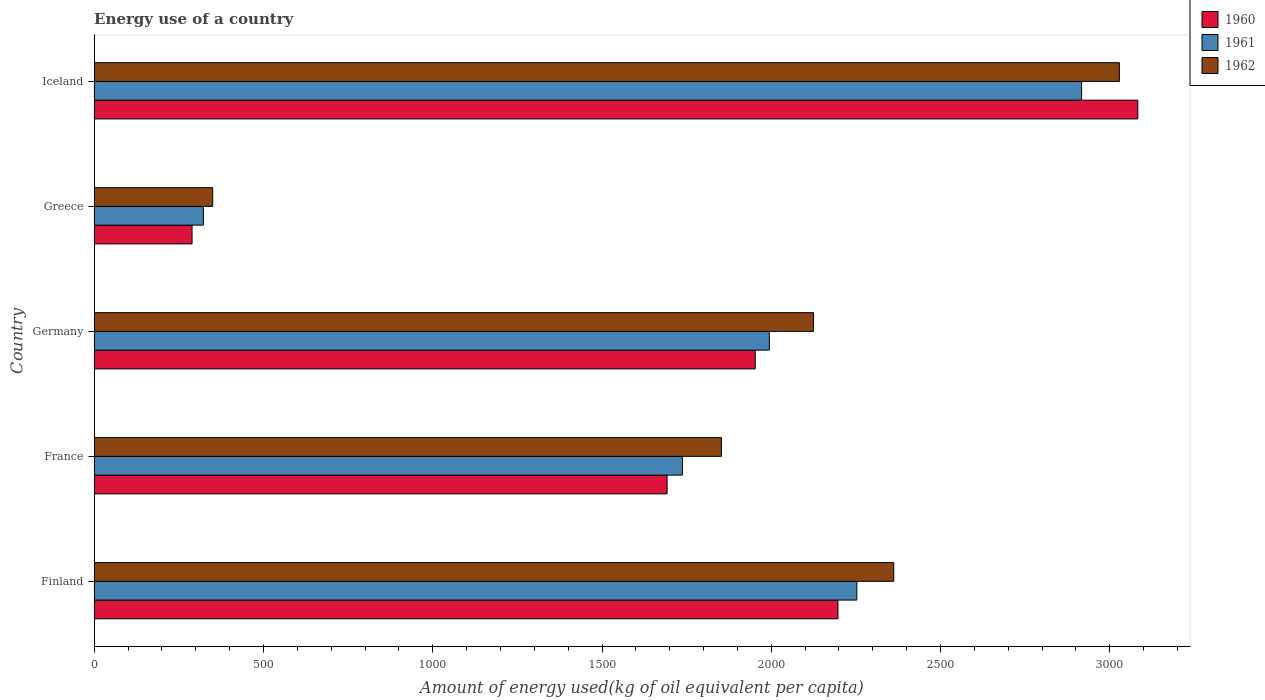How many different coloured bars are there?
Your answer should be very brief. 3. Are the number of bars per tick equal to the number of legend labels?
Give a very brief answer. Yes. What is the amount of energy used in in 1962 in France?
Keep it short and to the point. 1852.74. Across all countries, what is the maximum amount of energy used in in 1960?
Provide a succinct answer. 3082.71. Across all countries, what is the minimum amount of energy used in in 1961?
Your answer should be very brief. 322.49. In which country was the amount of energy used in in 1962 maximum?
Your answer should be very brief. Iceland. In which country was the amount of energy used in in 1960 minimum?
Make the answer very short. Greece. What is the total amount of energy used in in 1961 in the graph?
Offer a terse response. 9223.99. What is the difference between the amount of energy used in in 1961 in France and that in Greece?
Provide a succinct answer. 1415.2. What is the difference between the amount of energy used in in 1961 in Iceland and the amount of energy used in in 1960 in France?
Your answer should be very brief. 1224.44. What is the average amount of energy used in in 1961 per country?
Offer a very short reply. 1844.8. What is the difference between the amount of energy used in in 1962 and amount of energy used in in 1960 in Germany?
Offer a terse response. 172.26. What is the ratio of the amount of energy used in in 1960 in Finland to that in Greece?
Provide a succinct answer. 7.6. Is the amount of energy used in in 1960 in Germany less than that in Greece?
Your response must be concise. No. What is the difference between the highest and the second highest amount of energy used in in 1960?
Give a very brief answer. 885.76. What is the difference between the highest and the lowest amount of energy used in in 1961?
Provide a succinct answer. 2594.22. What does the 1st bar from the top in Germany represents?
Offer a very short reply. 1962. What does the 1st bar from the bottom in Greece represents?
Provide a short and direct response. 1960. How many bars are there?
Provide a succinct answer. 15. What is the difference between two consecutive major ticks on the X-axis?
Provide a short and direct response. 500. Are the values on the major ticks of X-axis written in scientific E-notation?
Give a very brief answer. No. Does the graph contain any zero values?
Ensure brevity in your answer.  No. Does the graph contain grids?
Offer a very short reply. No. How many legend labels are there?
Keep it short and to the point. 3. What is the title of the graph?
Your answer should be very brief. Energy use of a country. Does "1994" appear as one of the legend labels in the graph?
Offer a very short reply. No. What is the label or title of the X-axis?
Make the answer very short. Amount of energy used(kg of oil equivalent per capita). What is the label or title of the Y-axis?
Provide a short and direct response. Country. What is the Amount of energy used(kg of oil equivalent per capita) of 1960 in Finland?
Provide a succinct answer. 2196.95. What is the Amount of energy used(kg of oil equivalent per capita) in 1961 in Finland?
Your answer should be very brief. 2252.78. What is the Amount of energy used(kg of oil equivalent per capita) of 1962 in Finland?
Provide a short and direct response. 2361.74. What is the Amount of energy used(kg of oil equivalent per capita) of 1960 in France?
Offer a very short reply. 1692.26. What is the Amount of energy used(kg of oil equivalent per capita) in 1961 in France?
Keep it short and to the point. 1737.69. What is the Amount of energy used(kg of oil equivalent per capita) of 1962 in France?
Your answer should be very brief. 1852.74. What is the Amount of energy used(kg of oil equivalent per capita) of 1960 in Germany?
Ensure brevity in your answer.  1952.59. What is the Amount of energy used(kg of oil equivalent per capita) in 1961 in Germany?
Provide a succinct answer. 1994.32. What is the Amount of energy used(kg of oil equivalent per capita) of 1962 in Germany?
Give a very brief answer. 2124.85. What is the Amount of energy used(kg of oil equivalent per capita) in 1960 in Greece?
Ensure brevity in your answer.  289.06. What is the Amount of energy used(kg of oil equivalent per capita) of 1961 in Greece?
Offer a terse response. 322.49. What is the Amount of energy used(kg of oil equivalent per capita) of 1962 in Greece?
Offer a very short reply. 350.1. What is the Amount of energy used(kg of oil equivalent per capita) in 1960 in Iceland?
Your answer should be very brief. 3082.71. What is the Amount of energy used(kg of oil equivalent per capita) in 1961 in Iceland?
Give a very brief answer. 2916.71. What is the Amount of energy used(kg of oil equivalent per capita) of 1962 in Iceland?
Keep it short and to the point. 3028.3. Across all countries, what is the maximum Amount of energy used(kg of oil equivalent per capita) of 1960?
Provide a succinct answer. 3082.71. Across all countries, what is the maximum Amount of energy used(kg of oil equivalent per capita) of 1961?
Make the answer very short. 2916.71. Across all countries, what is the maximum Amount of energy used(kg of oil equivalent per capita) in 1962?
Keep it short and to the point. 3028.3. Across all countries, what is the minimum Amount of energy used(kg of oil equivalent per capita) of 1960?
Provide a succinct answer. 289.06. Across all countries, what is the minimum Amount of energy used(kg of oil equivalent per capita) of 1961?
Ensure brevity in your answer.  322.49. Across all countries, what is the minimum Amount of energy used(kg of oil equivalent per capita) of 1962?
Give a very brief answer. 350.1. What is the total Amount of energy used(kg of oil equivalent per capita) of 1960 in the graph?
Give a very brief answer. 9213.57. What is the total Amount of energy used(kg of oil equivalent per capita) of 1961 in the graph?
Give a very brief answer. 9223.99. What is the total Amount of energy used(kg of oil equivalent per capita) in 1962 in the graph?
Give a very brief answer. 9717.73. What is the difference between the Amount of energy used(kg of oil equivalent per capita) of 1960 in Finland and that in France?
Your response must be concise. 504.69. What is the difference between the Amount of energy used(kg of oil equivalent per capita) in 1961 in Finland and that in France?
Keep it short and to the point. 515.09. What is the difference between the Amount of energy used(kg of oil equivalent per capita) in 1962 in Finland and that in France?
Provide a succinct answer. 509.01. What is the difference between the Amount of energy used(kg of oil equivalent per capita) of 1960 in Finland and that in Germany?
Your answer should be very brief. 244.36. What is the difference between the Amount of energy used(kg of oil equivalent per capita) in 1961 in Finland and that in Germany?
Give a very brief answer. 258.45. What is the difference between the Amount of energy used(kg of oil equivalent per capita) of 1962 in Finland and that in Germany?
Keep it short and to the point. 236.9. What is the difference between the Amount of energy used(kg of oil equivalent per capita) in 1960 in Finland and that in Greece?
Your response must be concise. 1907.9. What is the difference between the Amount of energy used(kg of oil equivalent per capita) of 1961 in Finland and that in Greece?
Your answer should be very brief. 1930.29. What is the difference between the Amount of energy used(kg of oil equivalent per capita) of 1962 in Finland and that in Greece?
Your answer should be very brief. 2011.64. What is the difference between the Amount of energy used(kg of oil equivalent per capita) of 1960 in Finland and that in Iceland?
Provide a short and direct response. -885.76. What is the difference between the Amount of energy used(kg of oil equivalent per capita) of 1961 in Finland and that in Iceland?
Your response must be concise. -663.93. What is the difference between the Amount of energy used(kg of oil equivalent per capita) of 1962 in Finland and that in Iceland?
Your answer should be very brief. -666.55. What is the difference between the Amount of energy used(kg of oil equivalent per capita) of 1960 in France and that in Germany?
Your answer should be compact. -260.33. What is the difference between the Amount of energy used(kg of oil equivalent per capita) of 1961 in France and that in Germany?
Offer a very short reply. -256.64. What is the difference between the Amount of energy used(kg of oil equivalent per capita) in 1962 in France and that in Germany?
Provide a short and direct response. -272.11. What is the difference between the Amount of energy used(kg of oil equivalent per capita) in 1960 in France and that in Greece?
Your response must be concise. 1403.2. What is the difference between the Amount of energy used(kg of oil equivalent per capita) in 1961 in France and that in Greece?
Offer a very short reply. 1415.2. What is the difference between the Amount of energy used(kg of oil equivalent per capita) of 1962 in France and that in Greece?
Provide a short and direct response. 1502.63. What is the difference between the Amount of energy used(kg of oil equivalent per capita) in 1960 in France and that in Iceland?
Keep it short and to the point. -1390.45. What is the difference between the Amount of energy used(kg of oil equivalent per capita) in 1961 in France and that in Iceland?
Offer a terse response. -1179.02. What is the difference between the Amount of energy used(kg of oil equivalent per capita) in 1962 in France and that in Iceland?
Provide a short and direct response. -1175.56. What is the difference between the Amount of energy used(kg of oil equivalent per capita) in 1960 in Germany and that in Greece?
Your answer should be compact. 1663.53. What is the difference between the Amount of energy used(kg of oil equivalent per capita) in 1961 in Germany and that in Greece?
Offer a terse response. 1671.83. What is the difference between the Amount of energy used(kg of oil equivalent per capita) of 1962 in Germany and that in Greece?
Make the answer very short. 1774.75. What is the difference between the Amount of energy used(kg of oil equivalent per capita) of 1960 in Germany and that in Iceland?
Give a very brief answer. -1130.12. What is the difference between the Amount of energy used(kg of oil equivalent per capita) in 1961 in Germany and that in Iceland?
Ensure brevity in your answer.  -922.38. What is the difference between the Amount of energy used(kg of oil equivalent per capita) in 1962 in Germany and that in Iceland?
Keep it short and to the point. -903.45. What is the difference between the Amount of energy used(kg of oil equivalent per capita) of 1960 in Greece and that in Iceland?
Provide a succinct answer. -2793.65. What is the difference between the Amount of energy used(kg of oil equivalent per capita) in 1961 in Greece and that in Iceland?
Ensure brevity in your answer.  -2594.22. What is the difference between the Amount of energy used(kg of oil equivalent per capita) of 1962 in Greece and that in Iceland?
Provide a short and direct response. -2678.2. What is the difference between the Amount of energy used(kg of oil equivalent per capita) in 1960 in Finland and the Amount of energy used(kg of oil equivalent per capita) in 1961 in France?
Provide a short and direct response. 459.26. What is the difference between the Amount of energy used(kg of oil equivalent per capita) of 1960 in Finland and the Amount of energy used(kg of oil equivalent per capita) of 1962 in France?
Provide a succinct answer. 344.22. What is the difference between the Amount of energy used(kg of oil equivalent per capita) of 1961 in Finland and the Amount of energy used(kg of oil equivalent per capita) of 1962 in France?
Keep it short and to the point. 400.04. What is the difference between the Amount of energy used(kg of oil equivalent per capita) of 1960 in Finland and the Amount of energy used(kg of oil equivalent per capita) of 1961 in Germany?
Ensure brevity in your answer.  202.63. What is the difference between the Amount of energy used(kg of oil equivalent per capita) of 1960 in Finland and the Amount of energy used(kg of oil equivalent per capita) of 1962 in Germany?
Your response must be concise. 72.1. What is the difference between the Amount of energy used(kg of oil equivalent per capita) in 1961 in Finland and the Amount of energy used(kg of oil equivalent per capita) in 1962 in Germany?
Provide a succinct answer. 127.93. What is the difference between the Amount of energy used(kg of oil equivalent per capita) of 1960 in Finland and the Amount of energy used(kg of oil equivalent per capita) of 1961 in Greece?
Your answer should be compact. 1874.46. What is the difference between the Amount of energy used(kg of oil equivalent per capita) in 1960 in Finland and the Amount of energy used(kg of oil equivalent per capita) in 1962 in Greece?
Give a very brief answer. 1846.85. What is the difference between the Amount of energy used(kg of oil equivalent per capita) of 1961 in Finland and the Amount of energy used(kg of oil equivalent per capita) of 1962 in Greece?
Offer a terse response. 1902.68. What is the difference between the Amount of energy used(kg of oil equivalent per capita) of 1960 in Finland and the Amount of energy used(kg of oil equivalent per capita) of 1961 in Iceland?
Make the answer very short. -719.75. What is the difference between the Amount of energy used(kg of oil equivalent per capita) in 1960 in Finland and the Amount of energy used(kg of oil equivalent per capita) in 1962 in Iceland?
Ensure brevity in your answer.  -831.35. What is the difference between the Amount of energy used(kg of oil equivalent per capita) in 1961 in Finland and the Amount of energy used(kg of oil equivalent per capita) in 1962 in Iceland?
Offer a very short reply. -775.52. What is the difference between the Amount of energy used(kg of oil equivalent per capita) in 1960 in France and the Amount of energy used(kg of oil equivalent per capita) in 1961 in Germany?
Offer a very short reply. -302.06. What is the difference between the Amount of energy used(kg of oil equivalent per capita) of 1960 in France and the Amount of energy used(kg of oil equivalent per capita) of 1962 in Germany?
Your answer should be compact. -432.59. What is the difference between the Amount of energy used(kg of oil equivalent per capita) of 1961 in France and the Amount of energy used(kg of oil equivalent per capita) of 1962 in Germany?
Ensure brevity in your answer.  -387.16. What is the difference between the Amount of energy used(kg of oil equivalent per capita) of 1960 in France and the Amount of energy used(kg of oil equivalent per capita) of 1961 in Greece?
Provide a short and direct response. 1369.77. What is the difference between the Amount of energy used(kg of oil equivalent per capita) of 1960 in France and the Amount of energy used(kg of oil equivalent per capita) of 1962 in Greece?
Provide a succinct answer. 1342.16. What is the difference between the Amount of energy used(kg of oil equivalent per capita) of 1961 in France and the Amount of energy used(kg of oil equivalent per capita) of 1962 in Greece?
Offer a very short reply. 1387.59. What is the difference between the Amount of energy used(kg of oil equivalent per capita) of 1960 in France and the Amount of energy used(kg of oil equivalent per capita) of 1961 in Iceland?
Give a very brief answer. -1224.44. What is the difference between the Amount of energy used(kg of oil equivalent per capita) of 1960 in France and the Amount of energy used(kg of oil equivalent per capita) of 1962 in Iceland?
Offer a terse response. -1336.04. What is the difference between the Amount of energy used(kg of oil equivalent per capita) of 1961 in France and the Amount of energy used(kg of oil equivalent per capita) of 1962 in Iceland?
Make the answer very short. -1290.61. What is the difference between the Amount of energy used(kg of oil equivalent per capita) in 1960 in Germany and the Amount of energy used(kg of oil equivalent per capita) in 1961 in Greece?
Give a very brief answer. 1630.1. What is the difference between the Amount of energy used(kg of oil equivalent per capita) of 1960 in Germany and the Amount of energy used(kg of oil equivalent per capita) of 1962 in Greece?
Make the answer very short. 1602.49. What is the difference between the Amount of energy used(kg of oil equivalent per capita) of 1961 in Germany and the Amount of energy used(kg of oil equivalent per capita) of 1962 in Greece?
Your response must be concise. 1644.22. What is the difference between the Amount of energy used(kg of oil equivalent per capita) in 1960 in Germany and the Amount of energy used(kg of oil equivalent per capita) in 1961 in Iceland?
Offer a terse response. -964.12. What is the difference between the Amount of energy used(kg of oil equivalent per capita) of 1960 in Germany and the Amount of energy used(kg of oil equivalent per capita) of 1962 in Iceland?
Provide a short and direct response. -1075.71. What is the difference between the Amount of energy used(kg of oil equivalent per capita) in 1961 in Germany and the Amount of energy used(kg of oil equivalent per capita) in 1962 in Iceland?
Give a very brief answer. -1033.97. What is the difference between the Amount of energy used(kg of oil equivalent per capita) of 1960 in Greece and the Amount of energy used(kg of oil equivalent per capita) of 1961 in Iceland?
Offer a terse response. -2627.65. What is the difference between the Amount of energy used(kg of oil equivalent per capita) in 1960 in Greece and the Amount of energy used(kg of oil equivalent per capita) in 1962 in Iceland?
Your answer should be compact. -2739.24. What is the difference between the Amount of energy used(kg of oil equivalent per capita) in 1961 in Greece and the Amount of energy used(kg of oil equivalent per capita) in 1962 in Iceland?
Your answer should be very brief. -2705.81. What is the average Amount of energy used(kg of oil equivalent per capita) in 1960 per country?
Offer a terse response. 1842.71. What is the average Amount of energy used(kg of oil equivalent per capita) in 1961 per country?
Your answer should be very brief. 1844.8. What is the average Amount of energy used(kg of oil equivalent per capita) in 1962 per country?
Give a very brief answer. 1943.55. What is the difference between the Amount of energy used(kg of oil equivalent per capita) of 1960 and Amount of energy used(kg of oil equivalent per capita) of 1961 in Finland?
Offer a very short reply. -55.83. What is the difference between the Amount of energy used(kg of oil equivalent per capita) in 1960 and Amount of energy used(kg of oil equivalent per capita) in 1962 in Finland?
Your response must be concise. -164.79. What is the difference between the Amount of energy used(kg of oil equivalent per capita) of 1961 and Amount of energy used(kg of oil equivalent per capita) of 1962 in Finland?
Your response must be concise. -108.97. What is the difference between the Amount of energy used(kg of oil equivalent per capita) of 1960 and Amount of energy used(kg of oil equivalent per capita) of 1961 in France?
Provide a succinct answer. -45.43. What is the difference between the Amount of energy used(kg of oil equivalent per capita) of 1960 and Amount of energy used(kg of oil equivalent per capita) of 1962 in France?
Keep it short and to the point. -160.47. What is the difference between the Amount of energy used(kg of oil equivalent per capita) of 1961 and Amount of energy used(kg of oil equivalent per capita) of 1962 in France?
Your response must be concise. -115.05. What is the difference between the Amount of energy used(kg of oil equivalent per capita) in 1960 and Amount of energy used(kg of oil equivalent per capita) in 1961 in Germany?
Keep it short and to the point. -41.74. What is the difference between the Amount of energy used(kg of oil equivalent per capita) in 1960 and Amount of energy used(kg of oil equivalent per capita) in 1962 in Germany?
Your answer should be very brief. -172.26. What is the difference between the Amount of energy used(kg of oil equivalent per capita) in 1961 and Amount of energy used(kg of oil equivalent per capita) in 1962 in Germany?
Your response must be concise. -130.52. What is the difference between the Amount of energy used(kg of oil equivalent per capita) of 1960 and Amount of energy used(kg of oil equivalent per capita) of 1961 in Greece?
Make the answer very short. -33.43. What is the difference between the Amount of energy used(kg of oil equivalent per capita) in 1960 and Amount of energy used(kg of oil equivalent per capita) in 1962 in Greece?
Ensure brevity in your answer.  -61.04. What is the difference between the Amount of energy used(kg of oil equivalent per capita) in 1961 and Amount of energy used(kg of oil equivalent per capita) in 1962 in Greece?
Ensure brevity in your answer.  -27.61. What is the difference between the Amount of energy used(kg of oil equivalent per capita) of 1960 and Amount of energy used(kg of oil equivalent per capita) of 1961 in Iceland?
Give a very brief answer. 166.01. What is the difference between the Amount of energy used(kg of oil equivalent per capita) in 1960 and Amount of energy used(kg of oil equivalent per capita) in 1962 in Iceland?
Provide a short and direct response. 54.41. What is the difference between the Amount of energy used(kg of oil equivalent per capita) of 1961 and Amount of energy used(kg of oil equivalent per capita) of 1962 in Iceland?
Keep it short and to the point. -111.59. What is the ratio of the Amount of energy used(kg of oil equivalent per capita) of 1960 in Finland to that in France?
Give a very brief answer. 1.3. What is the ratio of the Amount of energy used(kg of oil equivalent per capita) in 1961 in Finland to that in France?
Provide a short and direct response. 1.3. What is the ratio of the Amount of energy used(kg of oil equivalent per capita) of 1962 in Finland to that in France?
Your answer should be very brief. 1.27. What is the ratio of the Amount of energy used(kg of oil equivalent per capita) in 1960 in Finland to that in Germany?
Ensure brevity in your answer.  1.13. What is the ratio of the Amount of energy used(kg of oil equivalent per capita) of 1961 in Finland to that in Germany?
Give a very brief answer. 1.13. What is the ratio of the Amount of energy used(kg of oil equivalent per capita) of 1962 in Finland to that in Germany?
Ensure brevity in your answer.  1.11. What is the ratio of the Amount of energy used(kg of oil equivalent per capita) in 1960 in Finland to that in Greece?
Offer a very short reply. 7.6. What is the ratio of the Amount of energy used(kg of oil equivalent per capita) in 1961 in Finland to that in Greece?
Ensure brevity in your answer.  6.99. What is the ratio of the Amount of energy used(kg of oil equivalent per capita) of 1962 in Finland to that in Greece?
Keep it short and to the point. 6.75. What is the ratio of the Amount of energy used(kg of oil equivalent per capita) in 1960 in Finland to that in Iceland?
Provide a succinct answer. 0.71. What is the ratio of the Amount of energy used(kg of oil equivalent per capita) of 1961 in Finland to that in Iceland?
Give a very brief answer. 0.77. What is the ratio of the Amount of energy used(kg of oil equivalent per capita) in 1962 in Finland to that in Iceland?
Offer a very short reply. 0.78. What is the ratio of the Amount of energy used(kg of oil equivalent per capita) in 1960 in France to that in Germany?
Offer a terse response. 0.87. What is the ratio of the Amount of energy used(kg of oil equivalent per capita) of 1961 in France to that in Germany?
Ensure brevity in your answer.  0.87. What is the ratio of the Amount of energy used(kg of oil equivalent per capita) in 1962 in France to that in Germany?
Offer a terse response. 0.87. What is the ratio of the Amount of energy used(kg of oil equivalent per capita) of 1960 in France to that in Greece?
Your response must be concise. 5.85. What is the ratio of the Amount of energy used(kg of oil equivalent per capita) in 1961 in France to that in Greece?
Provide a succinct answer. 5.39. What is the ratio of the Amount of energy used(kg of oil equivalent per capita) of 1962 in France to that in Greece?
Offer a very short reply. 5.29. What is the ratio of the Amount of energy used(kg of oil equivalent per capita) in 1960 in France to that in Iceland?
Keep it short and to the point. 0.55. What is the ratio of the Amount of energy used(kg of oil equivalent per capita) in 1961 in France to that in Iceland?
Offer a very short reply. 0.6. What is the ratio of the Amount of energy used(kg of oil equivalent per capita) of 1962 in France to that in Iceland?
Provide a succinct answer. 0.61. What is the ratio of the Amount of energy used(kg of oil equivalent per capita) in 1960 in Germany to that in Greece?
Make the answer very short. 6.75. What is the ratio of the Amount of energy used(kg of oil equivalent per capita) of 1961 in Germany to that in Greece?
Ensure brevity in your answer.  6.18. What is the ratio of the Amount of energy used(kg of oil equivalent per capita) in 1962 in Germany to that in Greece?
Ensure brevity in your answer.  6.07. What is the ratio of the Amount of energy used(kg of oil equivalent per capita) of 1960 in Germany to that in Iceland?
Your answer should be very brief. 0.63. What is the ratio of the Amount of energy used(kg of oil equivalent per capita) in 1961 in Germany to that in Iceland?
Make the answer very short. 0.68. What is the ratio of the Amount of energy used(kg of oil equivalent per capita) in 1962 in Germany to that in Iceland?
Keep it short and to the point. 0.7. What is the ratio of the Amount of energy used(kg of oil equivalent per capita) in 1960 in Greece to that in Iceland?
Your answer should be compact. 0.09. What is the ratio of the Amount of energy used(kg of oil equivalent per capita) of 1961 in Greece to that in Iceland?
Offer a terse response. 0.11. What is the ratio of the Amount of energy used(kg of oil equivalent per capita) in 1962 in Greece to that in Iceland?
Keep it short and to the point. 0.12. What is the difference between the highest and the second highest Amount of energy used(kg of oil equivalent per capita) of 1960?
Provide a short and direct response. 885.76. What is the difference between the highest and the second highest Amount of energy used(kg of oil equivalent per capita) in 1961?
Your response must be concise. 663.93. What is the difference between the highest and the second highest Amount of energy used(kg of oil equivalent per capita) of 1962?
Give a very brief answer. 666.55. What is the difference between the highest and the lowest Amount of energy used(kg of oil equivalent per capita) in 1960?
Your response must be concise. 2793.65. What is the difference between the highest and the lowest Amount of energy used(kg of oil equivalent per capita) of 1961?
Your answer should be very brief. 2594.22. What is the difference between the highest and the lowest Amount of energy used(kg of oil equivalent per capita) of 1962?
Keep it short and to the point. 2678.2. 